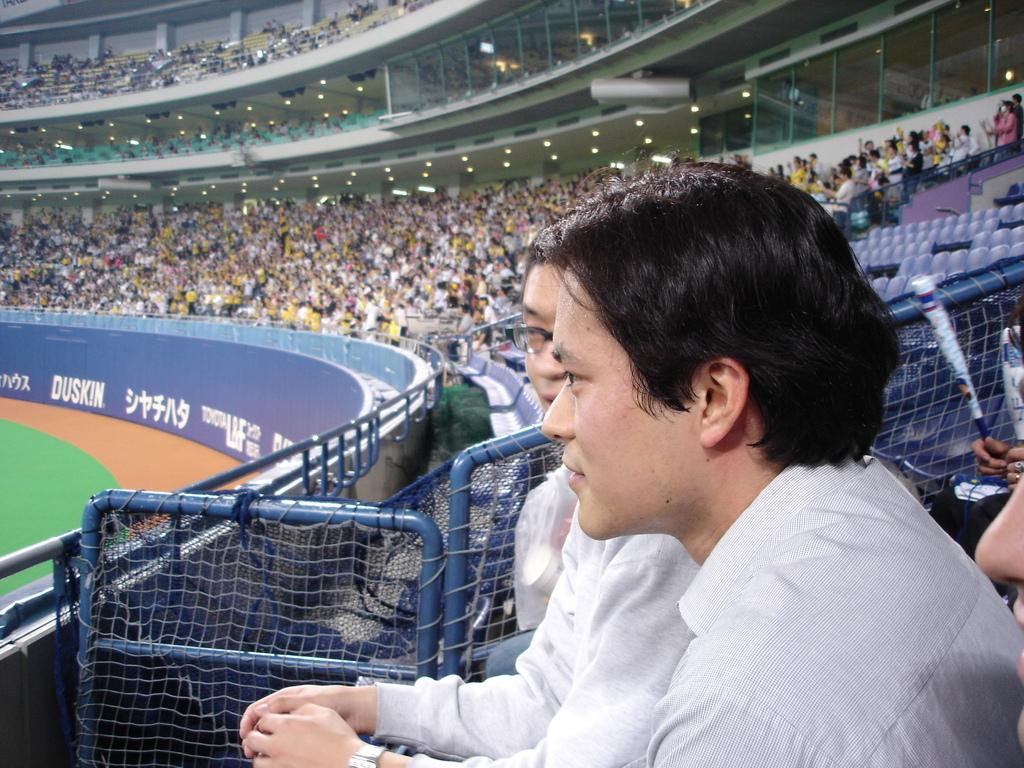How many persons are in the foreground of the image? There are two persons wearing white color shirts in the foreground of the image. What can be seen in the background of the image? There are people sitting in stands in the background of the image. What object is visible in the image that might be used for separating or dividing space? There is a net visible in the image. What type of reward is being handed out to the players in the image? There is no indication in the image that a reward is being handed out to the players. 